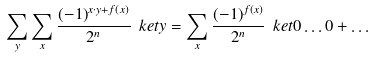Convert formula to latex. <formula><loc_0><loc_0><loc_500><loc_500>\sum _ { y } \sum _ { x } \frac { ( - 1 ) ^ { x \cdot y + f ( x ) } } { 2 ^ { n } } \ k e t { y } = \sum _ { x } \frac { ( - 1 ) ^ { f ( x ) } } { 2 ^ { n } } \ k e t { 0 \dots 0 } + \dots</formula> 